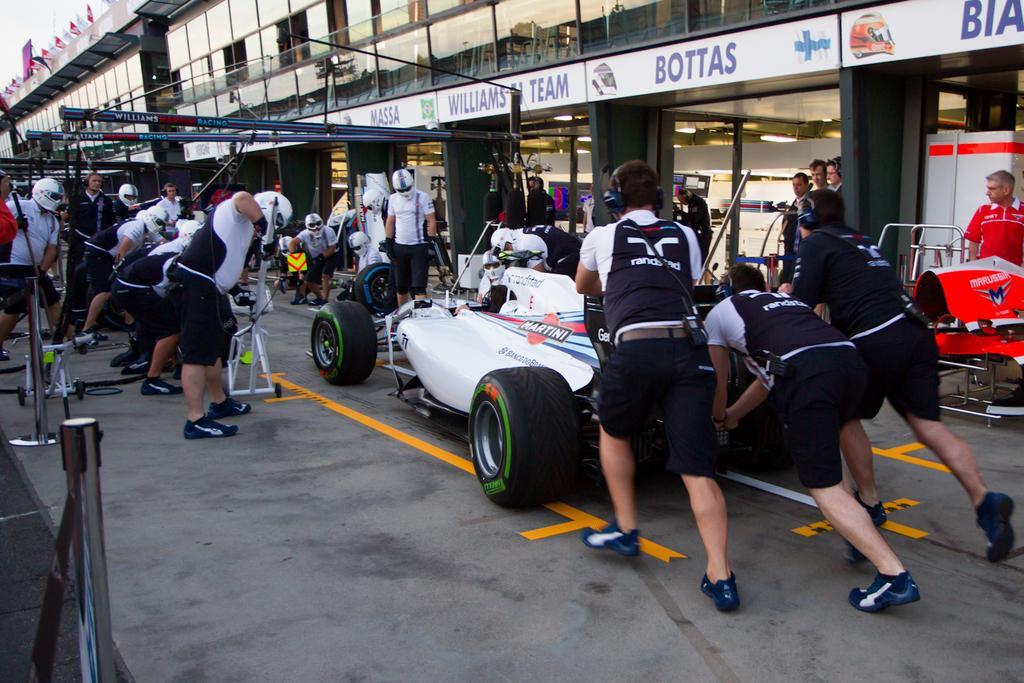Can you describe this image briefly? In this image we can see persons with some objects and there are three persons pushing the white color vehicle present on the road. In the background we can see a building. Image also consists of flags and also rods. 